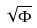<formula> <loc_0><loc_0><loc_500><loc_500>\sqrt { \Phi }</formula> 